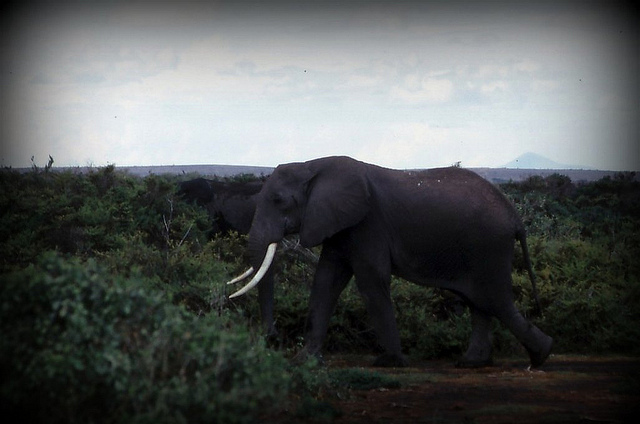<image>How tall are the tree's? I don't know how tall the trees are. It's possible there are no trees in the image. How tall are the tree's? It is ambiguous how tall the trees are in the image. It can be seen '12 feet', 'short', '5 ft', 'tall', '4 ft' or 'short'. 